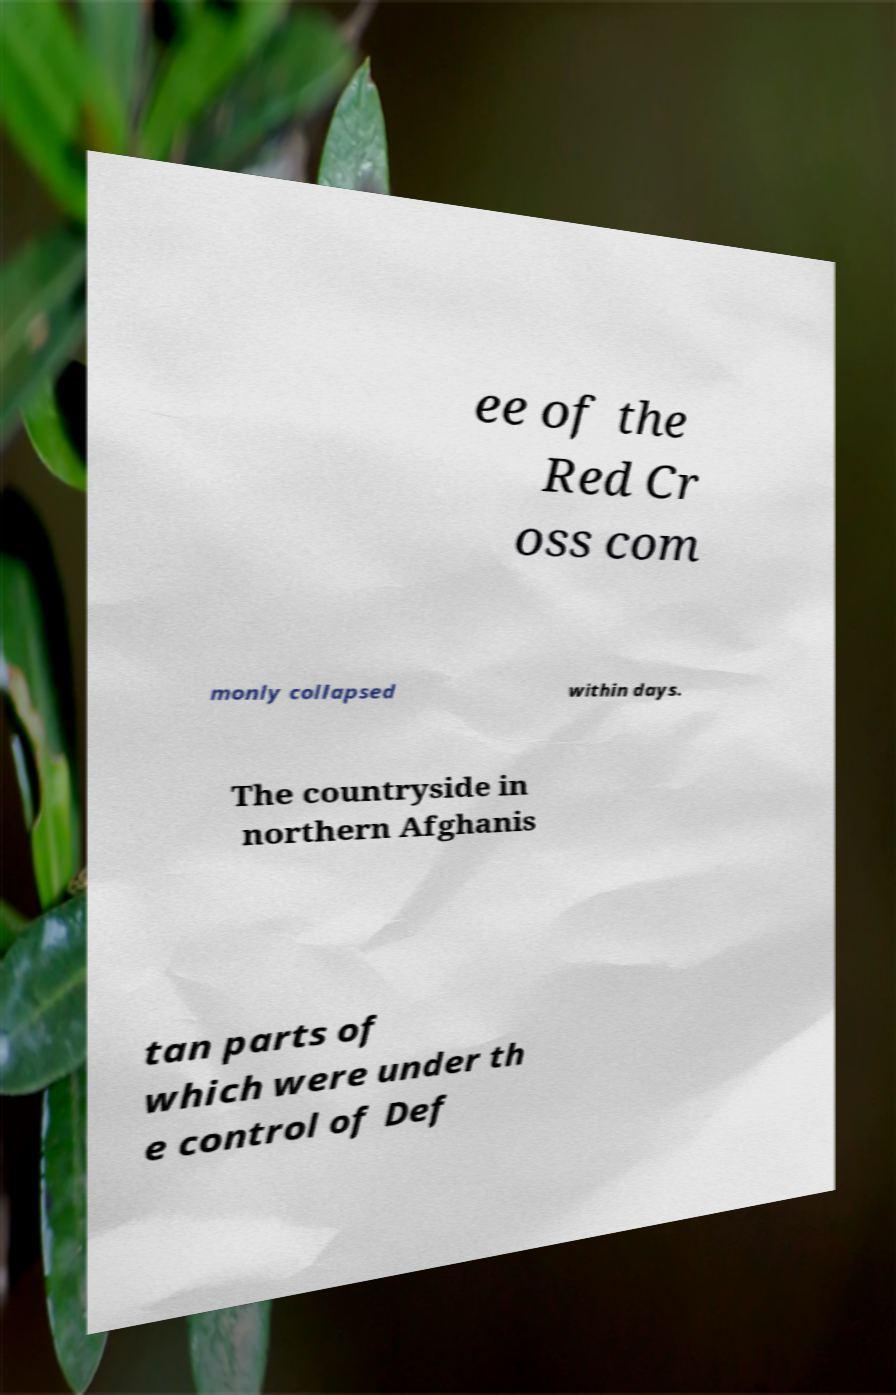Can you read and provide the text displayed in the image?This photo seems to have some interesting text. Can you extract and type it out for me? ee of the Red Cr oss com monly collapsed within days. The countryside in northern Afghanis tan parts of which were under th e control of Def 